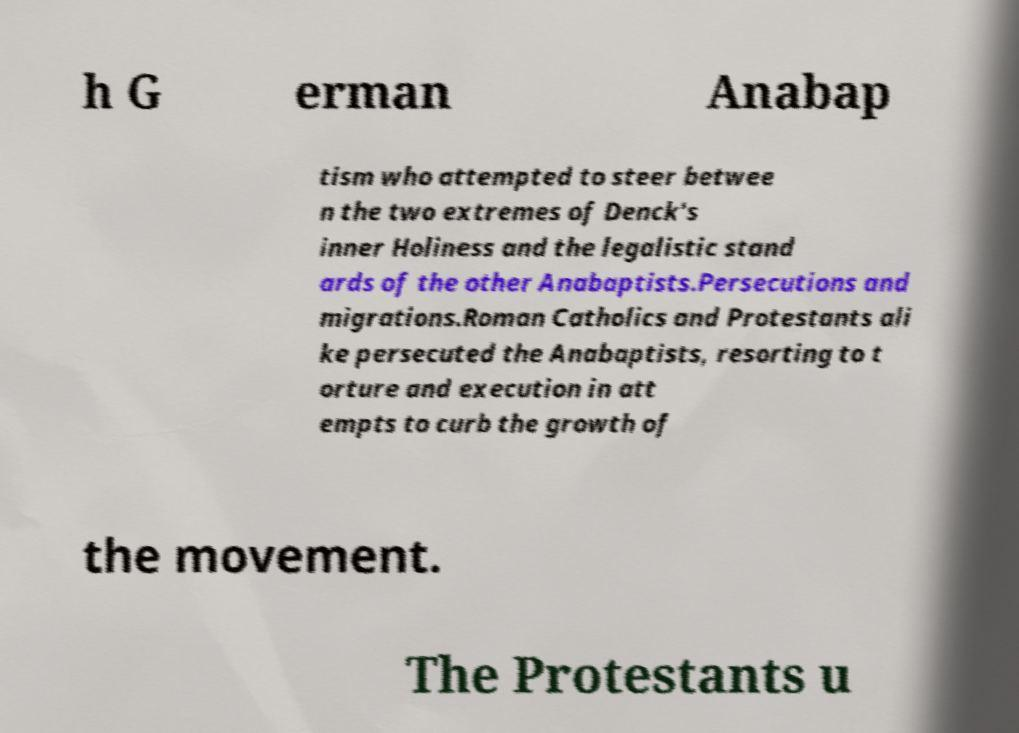For documentation purposes, I need the text within this image transcribed. Could you provide that? h G erman Anabap tism who attempted to steer betwee n the two extremes of Denck's inner Holiness and the legalistic stand ards of the other Anabaptists.Persecutions and migrations.Roman Catholics and Protestants ali ke persecuted the Anabaptists, resorting to t orture and execution in att empts to curb the growth of the movement. The Protestants u 